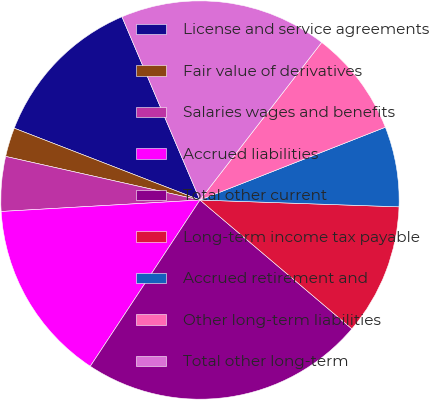<chart> <loc_0><loc_0><loc_500><loc_500><pie_chart><fcel>License and service agreements<fcel>Fair value of derivatives<fcel>Salaries wages and benefits<fcel>Accrued liabilities<fcel>Total other current<fcel>Long-term income tax payable<fcel>Accrued retirement and<fcel>Other long-term liabilities<fcel>Total other long-term<nl><fcel>12.72%<fcel>2.36%<fcel>4.43%<fcel>14.8%<fcel>23.09%<fcel>10.65%<fcel>6.5%<fcel>8.58%<fcel>16.87%<nl></chart> 